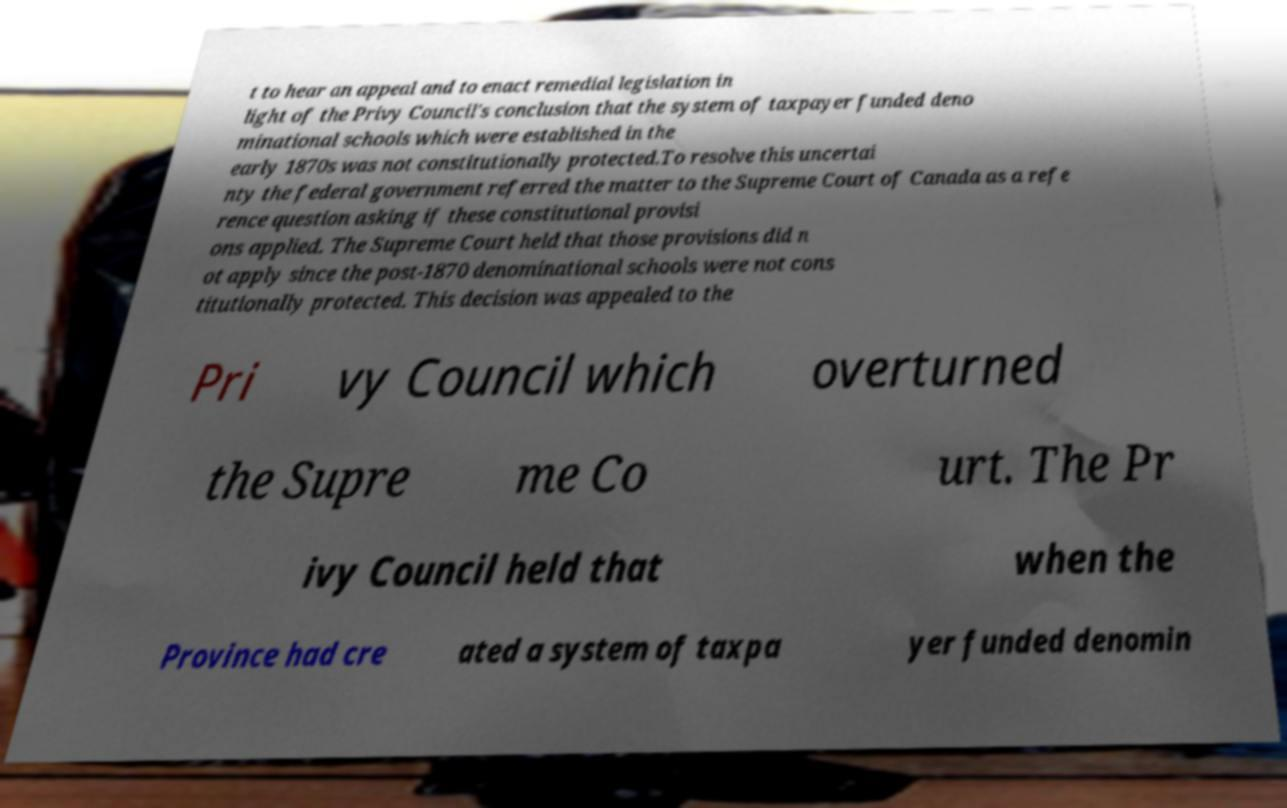Could you assist in decoding the text presented in this image and type it out clearly? t to hear an appeal and to enact remedial legislation in light of the Privy Council's conclusion that the system of taxpayer funded deno minational schools which were established in the early 1870s was not constitutionally protected.To resolve this uncertai nty the federal government referred the matter to the Supreme Court of Canada as a refe rence question asking if these constitutional provisi ons applied. The Supreme Court held that those provisions did n ot apply since the post-1870 denominational schools were not cons titutionally protected. This decision was appealed to the Pri vy Council which overturned the Supre me Co urt. The Pr ivy Council held that when the Province had cre ated a system of taxpa yer funded denomin 